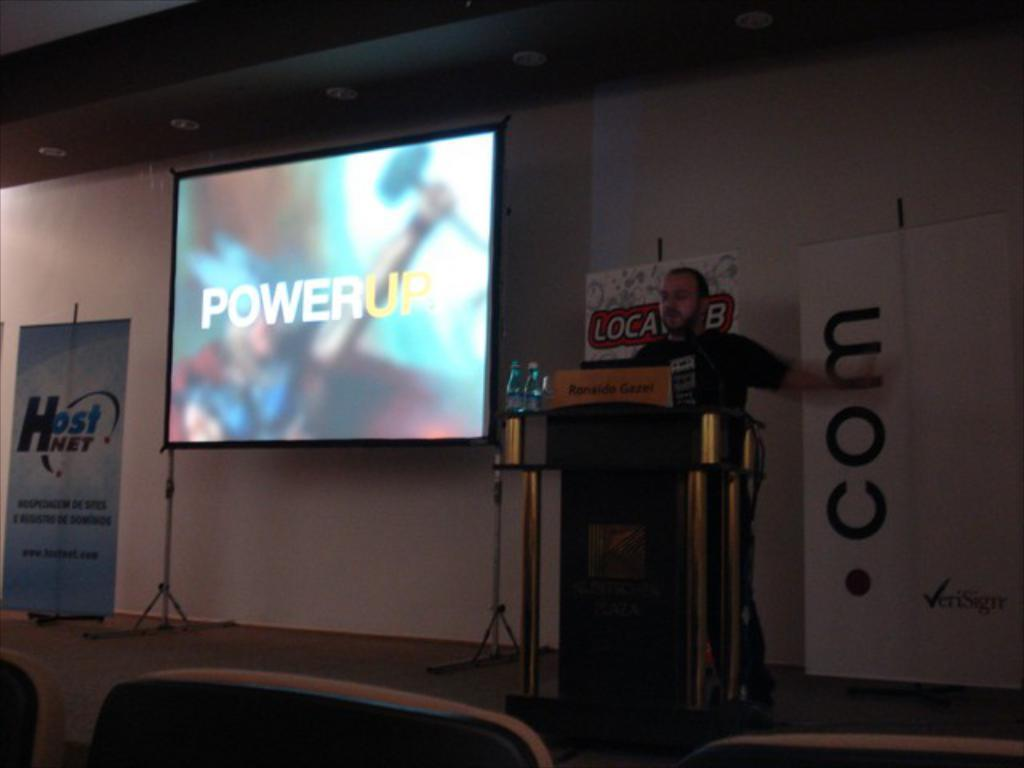<image>
Write a terse but informative summary of the picture. Speaker with a presentation on the screen titled PowerUp. 